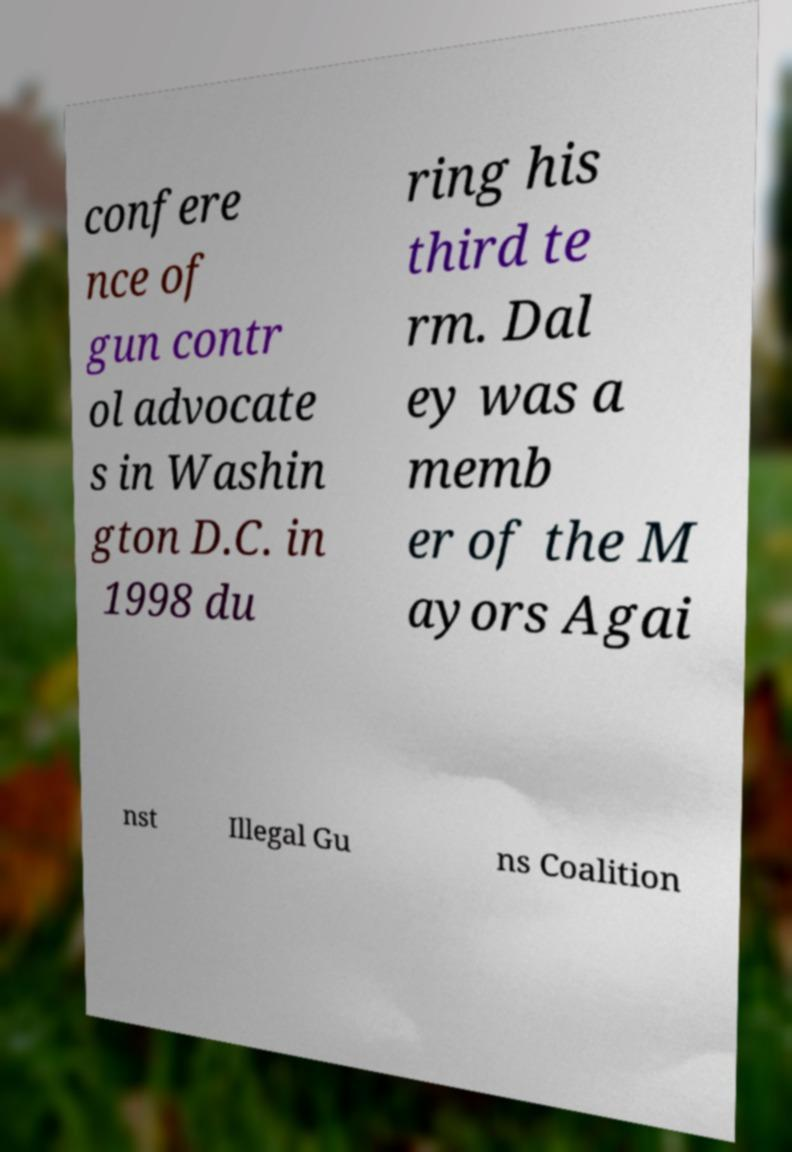I need the written content from this picture converted into text. Can you do that? confere nce of gun contr ol advocate s in Washin gton D.C. in 1998 du ring his third te rm. Dal ey was a memb er of the M ayors Agai nst Illegal Gu ns Coalition 